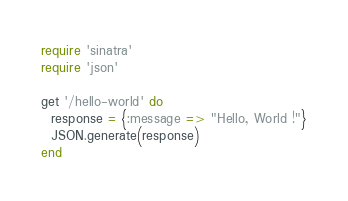<code> <loc_0><loc_0><loc_500><loc_500><_Ruby_>require 'sinatra'
require 'json'

get '/hello-world' do
  response = {:message => "Hello, World !"}
  JSON.generate(response)
end
</code> 